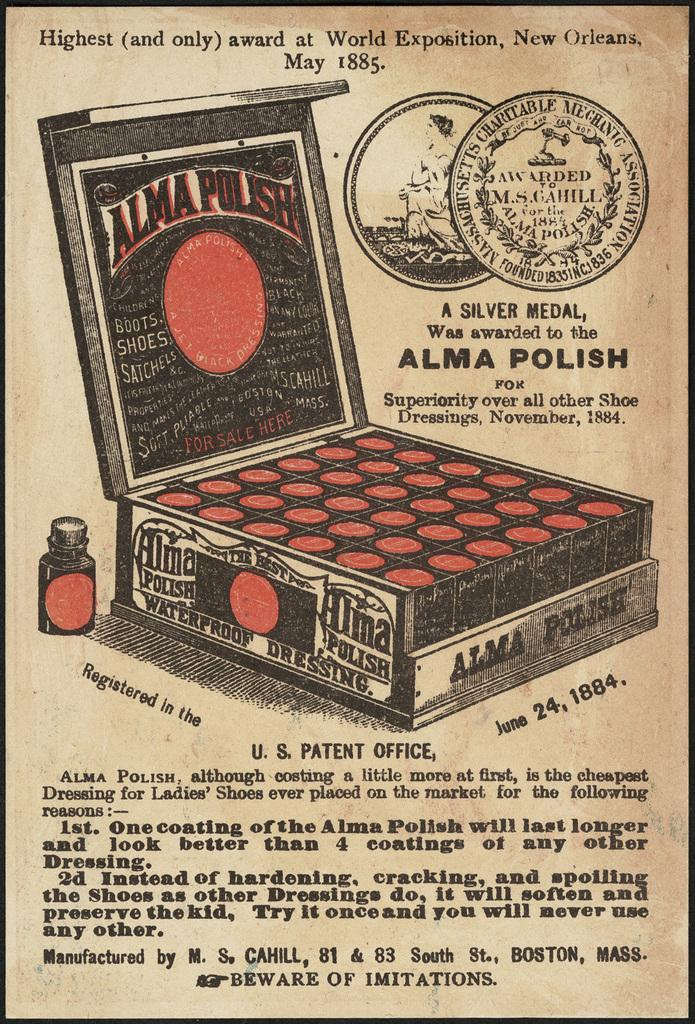<image>
Render a clear and concise summary of the photo. a poster that says 'alma polish' on it 